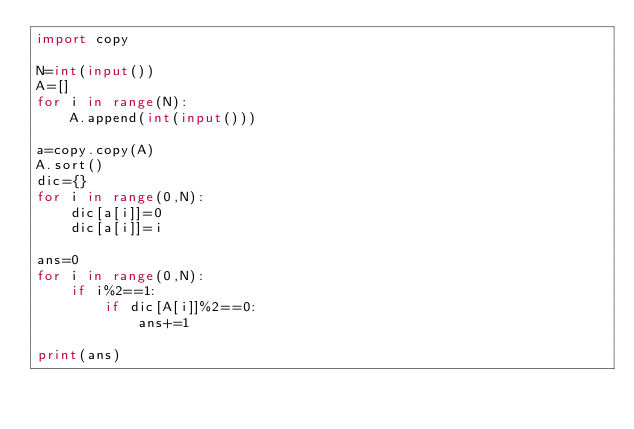<code> <loc_0><loc_0><loc_500><loc_500><_Python_>import copy

N=int(input())
A=[]
for i in range(N):
    A.append(int(input()))

a=copy.copy(A)
A.sort()
dic={}
for i in range(0,N):
    dic[a[i]]=0
    dic[a[i]]=i

ans=0
for i in range(0,N):
    if i%2==1:
        if dic[A[i]]%2==0:
            ans+=1

print(ans)</code> 